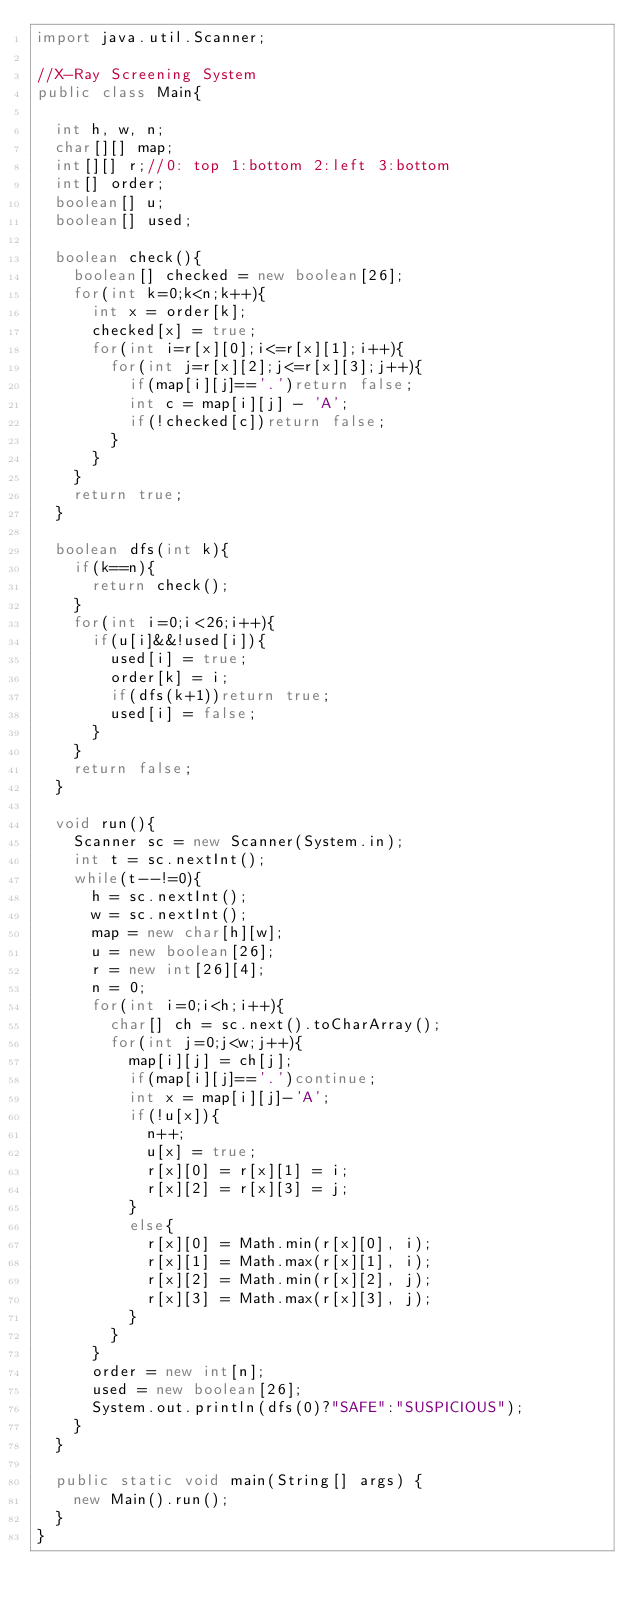<code> <loc_0><loc_0><loc_500><loc_500><_Java_>import java.util.Scanner;

//X-Ray Screening System
public class Main{

	int h, w, n;
	char[][] map;
	int[][] r;//0: top 1:bottom 2:left 3:bottom
	int[] order;
	boolean[] u;
	boolean[] used;
	
	boolean check(){
		boolean[] checked = new boolean[26];
		for(int k=0;k<n;k++){
			int x = order[k];
			checked[x] = true;
			for(int i=r[x][0];i<=r[x][1];i++){
				for(int j=r[x][2];j<=r[x][3];j++){
					if(map[i][j]=='.')return false;
					int c = map[i][j] - 'A';
					if(!checked[c])return false;
				}
			}
		}
		return true;
	}
	
	boolean dfs(int k){
		if(k==n){
			return check();
		}
		for(int i=0;i<26;i++){
			if(u[i]&&!used[i]){
				used[i] = true;
				order[k] = i;
				if(dfs(k+1))return true;
				used[i] = false;
			}
		}
		return false;
	}
	
	void run(){
		Scanner sc = new Scanner(System.in);
		int t = sc.nextInt();
		while(t--!=0){
			h = sc.nextInt();
			w = sc.nextInt();
			map = new char[h][w];
			u = new boolean[26];
			r = new int[26][4];
			n = 0;
			for(int i=0;i<h;i++){
				char[] ch = sc.next().toCharArray();
				for(int j=0;j<w;j++){
					map[i][j] = ch[j];
					if(map[i][j]=='.')continue;
					int x = map[i][j]-'A';
					if(!u[x]){
						n++;
						u[x] = true;
						r[x][0] = r[x][1] = i;
						r[x][2] = r[x][3] = j;
					}
					else{
						r[x][0] = Math.min(r[x][0], i);
						r[x][1] = Math.max(r[x][1], i);
						r[x][2] = Math.min(r[x][2], j);
						r[x][3] = Math.max(r[x][3], j);
					}
				}
			}
			order = new int[n];
			used = new boolean[26];
			System.out.println(dfs(0)?"SAFE":"SUSPICIOUS");
		}
	}
	
	public static void main(String[] args) {
		new Main().run();
	}
}</code> 